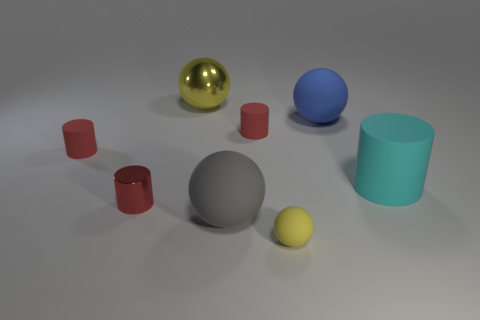Can you describe the lighting and shadows in the scene? Certainly! The image seems to be illuminated by a diffuse light source from above, casting subtle shadows directly underneath the objects. The shadows are soft-edged, which suggests that the light source is neither too close nor too harsh, creating a calm and balanced scene. 